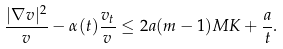Convert formula to latex. <formula><loc_0><loc_0><loc_500><loc_500>\frac { | \nabla v | ^ { 2 } } { v } - \alpha ( t ) \frac { v _ { t } } { v } \leq 2 a ( m - 1 ) M K + \frac { a } { t } .</formula> 